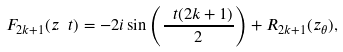Convert formula to latex. <formula><loc_0><loc_0><loc_500><loc_500>F _ { 2 k + 1 } ( z _ { \ } t ) = - 2 i \sin \left ( \frac { \ t ( 2 k + 1 ) } { 2 } \right ) + R _ { 2 k + 1 } ( z _ { \theta } ) ,</formula> 